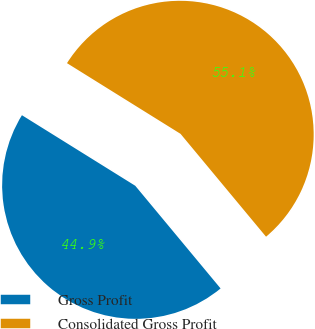Convert chart. <chart><loc_0><loc_0><loc_500><loc_500><pie_chart><fcel>Gross Profit<fcel>Consolidated Gross Profit<nl><fcel>44.9%<fcel>55.1%<nl></chart> 